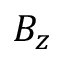<formula> <loc_0><loc_0><loc_500><loc_500>B _ { z }</formula> 